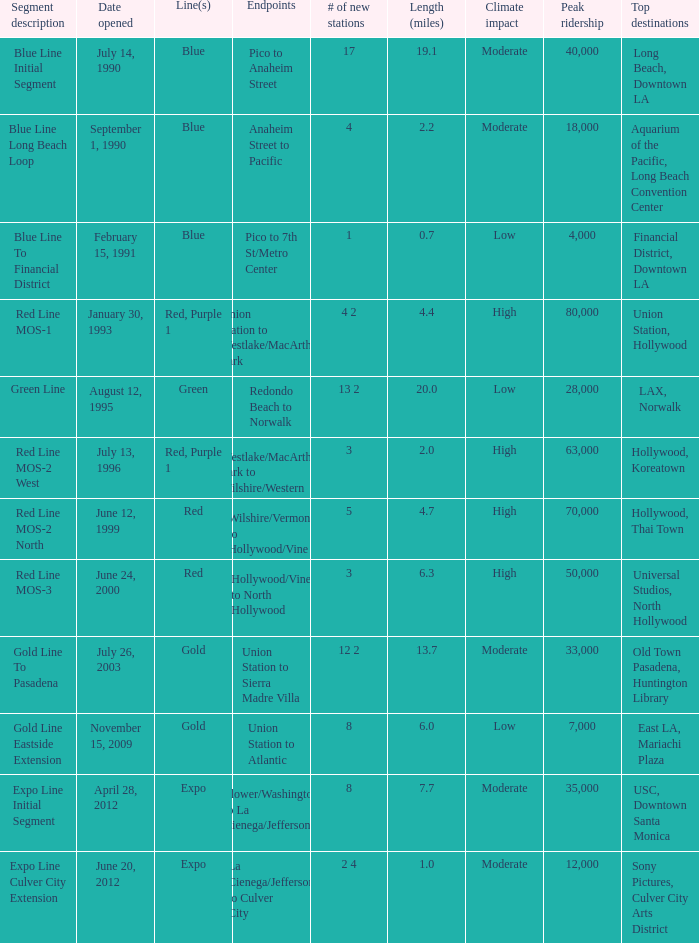How many lines have the segment description of red line mos-2 west? Red, Purple 1. 